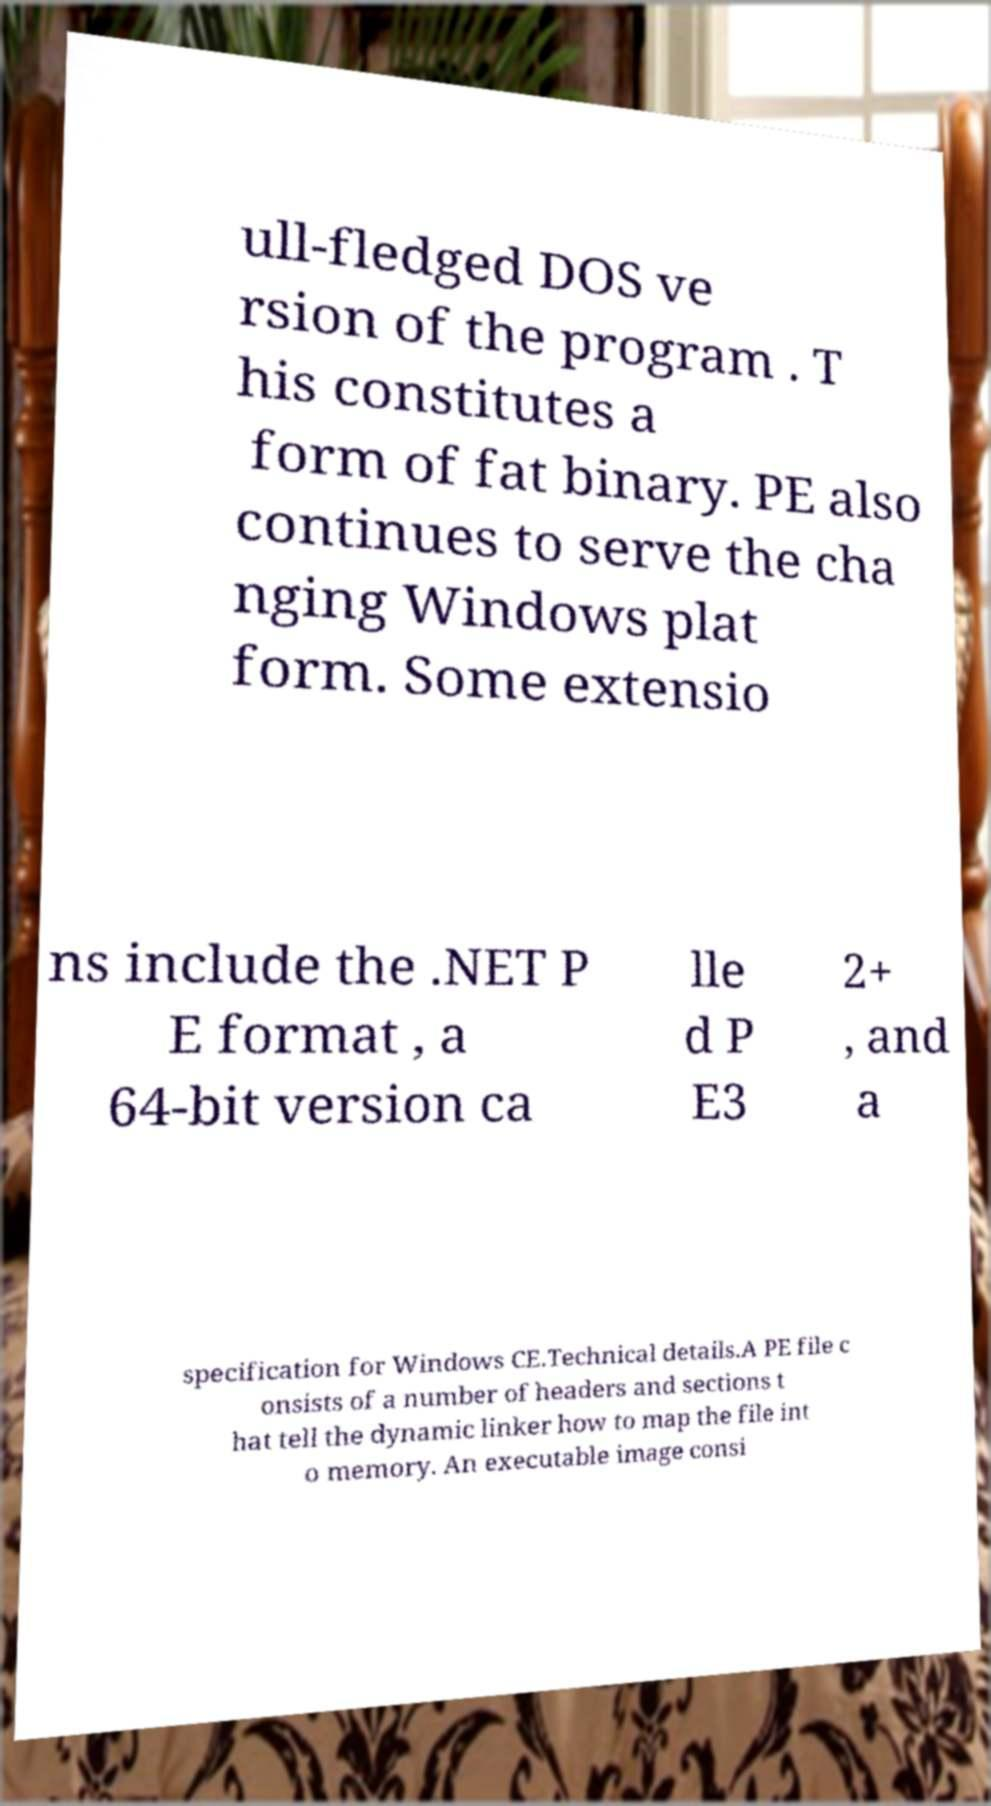Could you extract and type out the text from this image? ull-fledged DOS ve rsion of the program . T his constitutes a form of fat binary. PE also continues to serve the cha nging Windows plat form. Some extensio ns include the .NET P E format , a 64-bit version ca lle d P E3 2+ , and a specification for Windows CE.Technical details.A PE file c onsists of a number of headers and sections t hat tell the dynamic linker how to map the file int o memory. An executable image consi 